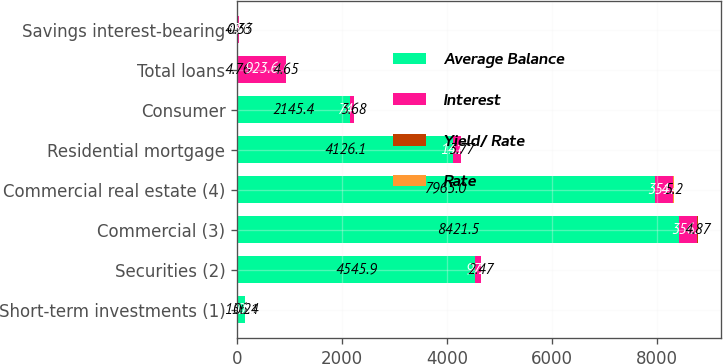<chart> <loc_0><loc_0><loc_500><loc_500><stacked_bar_chart><ecel><fcel>Short-term investments (1)<fcel>Securities (2)<fcel>Commercial (3)<fcel>Commercial real estate (4)<fcel>Residential mortgage<fcel>Consumer<fcel>Total loans<fcel>Savings interest-bearing<nl><fcel>Average Balance<fcel>156.1<fcel>4545.9<fcel>8421.5<fcel>7965<fcel>4126.1<fcel>2145.4<fcel>4.76<fcel>4.76<nl><fcel>Interest<fcel>0.3<fcel>97.7<fcel>356.2<fcel>351.2<fcel>141.4<fcel>74.8<fcel>923.6<fcel>33<nl><fcel>Yield/ Rate<fcel>0.22<fcel>2.15<fcel>4.23<fcel>4.41<fcel>3.42<fcel>3.49<fcel>4.08<fcel>0.27<nl><fcel>Rate<fcel>0.24<fcel>2.47<fcel>4.87<fcel>5.2<fcel>3.77<fcel>3.68<fcel>4.65<fcel>0.33<nl></chart> 